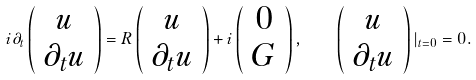Convert formula to latex. <formula><loc_0><loc_0><loc_500><loc_500>i \partial _ { t } \left ( \begin{array} { c } u \\ \partial _ { t } u \end{array} \right ) = R \left ( \begin{array} { c } u \\ \partial _ { t } u \end{array} \right ) + i \left ( \begin{array} { c } 0 \\ G \end{array} \right ) , \quad \left ( \begin{array} { c } u \\ \partial _ { t } u \end{array} \right ) | _ { t = 0 } = 0 .</formula> 